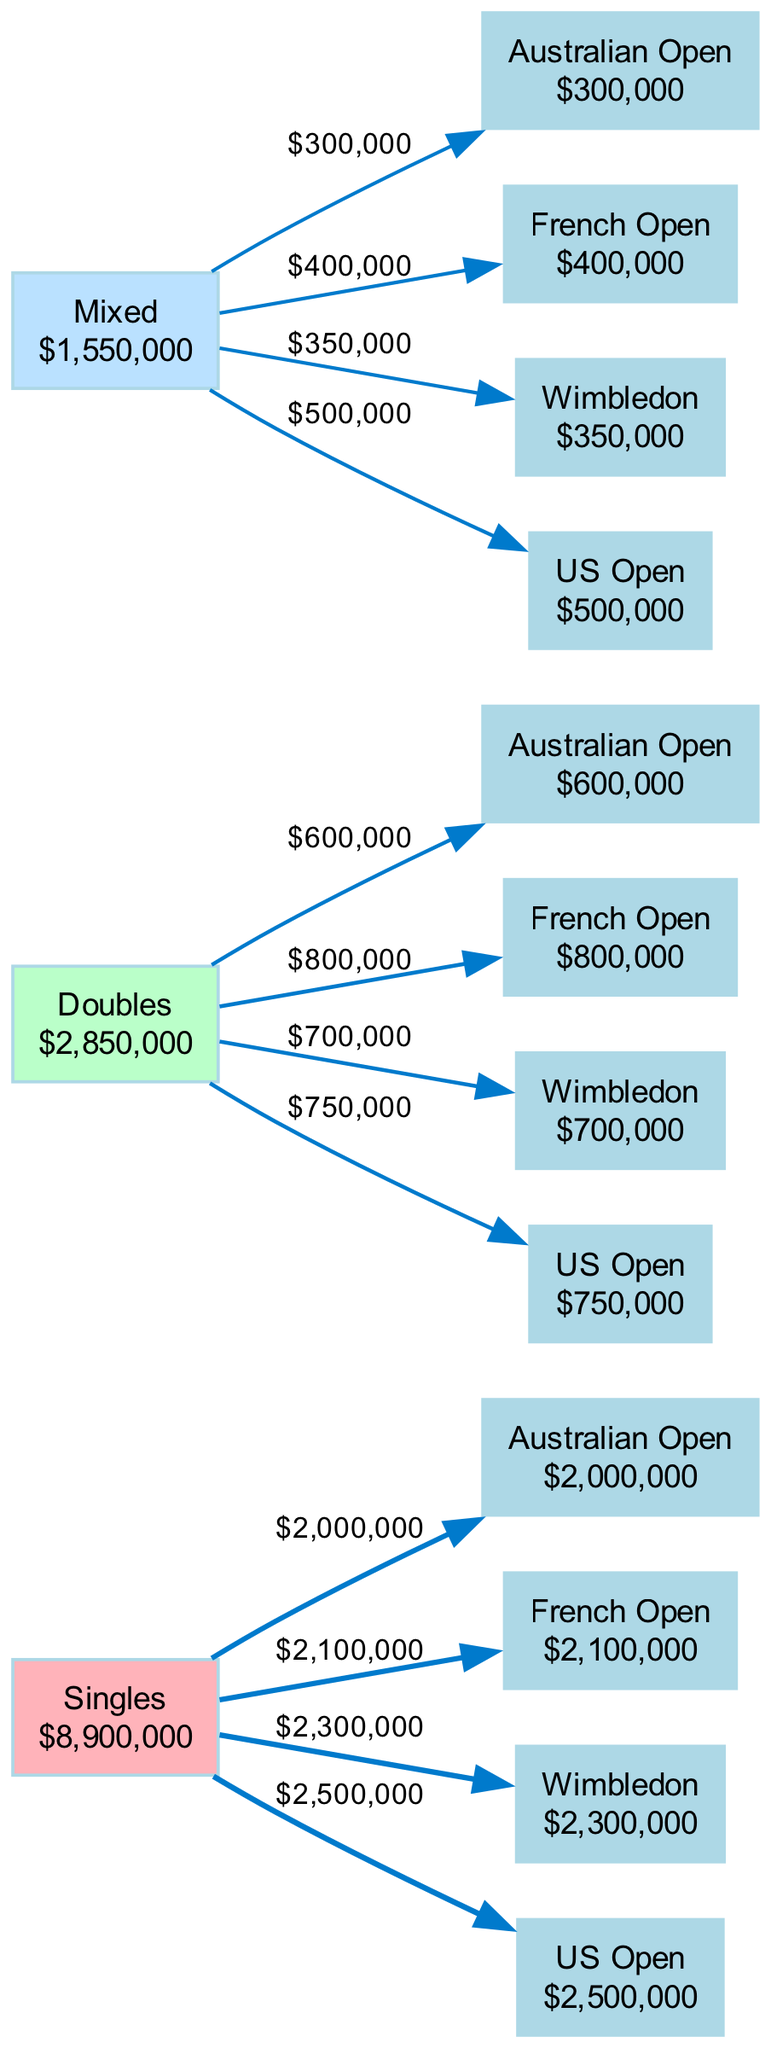What is the total earnings from the Singles category? To find the total earnings from the Singles category, we look at the tournament earnings listed under the Singles category: Australian Open ($2,000,000), French Open ($2,100,000), Wimbledon ($2,300,000), and US Open ($2,500,000). Summing these values gives $2,000,000 + $2,100,000 + $2,300,000 + $2,500,000 = $10,900,000.
Answer: 10,900,000 Which tournament provided the highest earnings in Doubles? Within the Doubles category, we examine the tournament earnings: Australian Open ($600,000), French Open ($800,000), Wimbledon ($700,000), and US Open ($750,000). The highest amount among these is from the French Open with $800,000.
Answer: French Open How many tournaments are listed under the Mixed category? The Mixed category displays four tournaments: Australian Open, French Open, Wimbledon, and US Open. Counting these gives us a total of four tournaments.
Answer: 4 Which event category has the lowest total earnings? To identify the category with the lowest total earnings, we need to look at the total for each category: Singles ($10,900,000), Doubles ($2,850,000), and Mixed ($1,550,000). Comparing these totals, the Mixed category has the lowest earnings at $1,550,000.
Answer: Mixed What is the earnings difference between Singles and Doubles categories? We first calculate the total earnings for each category: Singles ($10,900,000) and Doubles ($2,850,000). The difference is calculated by subtracting the Doubles total from the Singles total: $10,900,000 - $2,850,000 = $8,050,000.
Answer: 8,050,000 What was the total earnings from the US Open across all event categories? The US Open provides the following earnings: Singles ($2,500,000), Doubles ($750,000), and Mixed ($500,000). We sum these amounts: $2,500,000 + $750,000 + $500,000 = $3,750,000.
Answer: 3,750,000 Which tournament in the Singles category had the least earnings? For the Singles category tournaments, we see the following earnings: Australian Open ($2,000,000), French Open ($2,100,000), Wimbledon ($2,300,000), and US Open ($2,500,000). The least amount earned is from the Australian Open at $2,000,000.
Answer: Australian Open How does the US Open's Mixed category earnings compare to its Doubles category earnings? We first look at the earnings for each in the US Open: Mixed category earns $500,000, while Doubles earns $750,000. The question is asking for a comparison, and we know the Doubles earnings are higher than Mixed by $250,000.
Answer: 250,000 What percentage of total earnings does the Singles category represent? The total earnings across all categories can be calculated as follows: Singles ($10,900,000) + Doubles ($2,850,000) + Mixed ($1,550,000) = $15,300,000. The percentage of total earnings from the Singles category is calculated by dividing Singles' total by the overall total and multiplying by 100: ($10,900,000 / $15,300,000) * 100 ≈ 71.2%.
Answer: 71.2% 